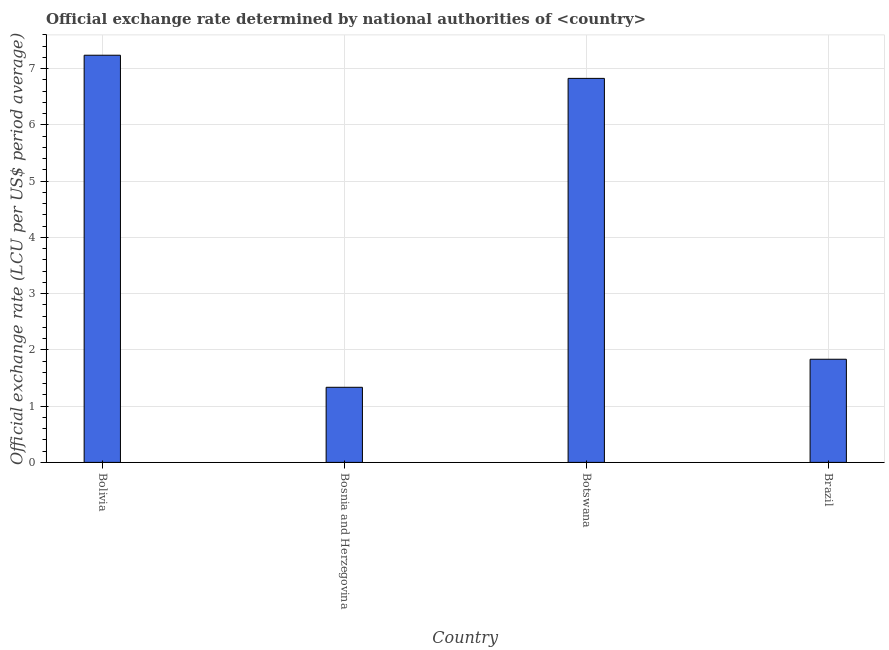What is the title of the graph?
Provide a succinct answer. Official exchange rate determined by national authorities of <country>. What is the label or title of the Y-axis?
Provide a short and direct response. Official exchange rate (LCU per US$ period average). What is the official exchange rate in Brazil?
Make the answer very short. 1.83. Across all countries, what is the maximum official exchange rate?
Provide a short and direct response. 7.24. Across all countries, what is the minimum official exchange rate?
Your answer should be compact. 1.34. In which country was the official exchange rate maximum?
Your answer should be very brief. Bolivia. In which country was the official exchange rate minimum?
Your answer should be very brief. Bosnia and Herzegovina. What is the sum of the official exchange rate?
Offer a terse response. 17.23. What is the difference between the official exchange rate in Bosnia and Herzegovina and Brazil?
Provide a succinct answer. -0.5. What is the average official exchange rate per country?
Provide a succinct answer. 4.31. What is the median official exchange rate?
Your answer should be very brief. 4.33. What is the ratio of the official exchange rate in Bosnia and Herzegovina to that in Botswana?
Ensure brevity in your answer.  0.2. What is the difference between the highest and the second highest official exchange rate?
Make the answer very short. 0.41. Is the sum of the official exchange rate in Bosnia and Herzegovina and Botswana greater than the maximum official exchange rate across all countries?
Your answer should be very brief. Yes. What is the difference between the highest and the lowest official exchange rate?
Ensure brevity in your answer.  5.9. How many bars are there?
Your answer should be compact. 4. How many countries are there in the graph?
Make the answer very short. 4. What is the difference between two consecutive major ticks on the Y-axis?
Keep it short and to the point. 1. What is the Official exchange rate (LCU per US$ period average) in Bolivia?
Give a very brief answer. 7.24. What is the Official exchange rate (LCU per US$ period average) in Bosnia and Herzegovina?
Your response must be concise. 1.34. What is the Official exchange rate (LCU per US$ period average) of Botswana?
Keep it short and to the point. 6.83. What is the Official exchange rate (LCU per US$ period average) in Brazil?
Keep it short and to the point. 1.83. What is the difference between the Official exchange rate (LCU per US$ period average) in Bolivia and Bosnia and Herzegovina?
Provide a succinct answer. 5.9. What is the difference between the Official exchange rate (LCU per US$ period average) in Bolivia and Botswana?
Your response must be concise. 0.41. What is the difference between the Official exchange rate (LCU per US$ period average) in Bolivia and Brazil?
Keep it short and to the point. 5.4. What is the difference between the Official exchange rate (LCU per US$ period average) in Bosnia and Herzegovina and Botswana?
Make the answer very short. -5.49. What is the difference between the Official exchange rate (LCU per US$ period average) in Bosnia and Herzegovina and Brazil?
Ensure brevity in your answer.  -0.5. What is the difference between the Official exchange rate (LCU per US$ period average) in Botswana and Brazil?
Keep it short and to the point. 4.99. What is the ratio of the Official exchange rate (LCU per US$ period average) in Bolivia to that in Bosnia and Herzegovina?
Make the answer very short. 5.42. What is the ratio of the Official exchange rate (LCU per US$ period average) in Bolivia to that in Botswana?
Your answer should be compact. 1.06. What is the ratio of the Official exchange rate (LCU per US$ period average) in Bolivia to that in Brazil?
Provide a succinct answer. 3.95. What is the ratio of the Official exchange rate (LCU per US$ period average) in Bosnia and Herzegovina to that in Botswana?
Make the answer very short. 0.2. What is the ratio of the Official exchange rate (LCU per US$ period average) in Bosnia and Herzegovina to that in Brazil?
Offer a terse response. 0.73. What is the ratio of the Official exchange rate (LCU per US$ period average) in Botswana to that in Brazil?
Give a very brief answer. 3.72. 